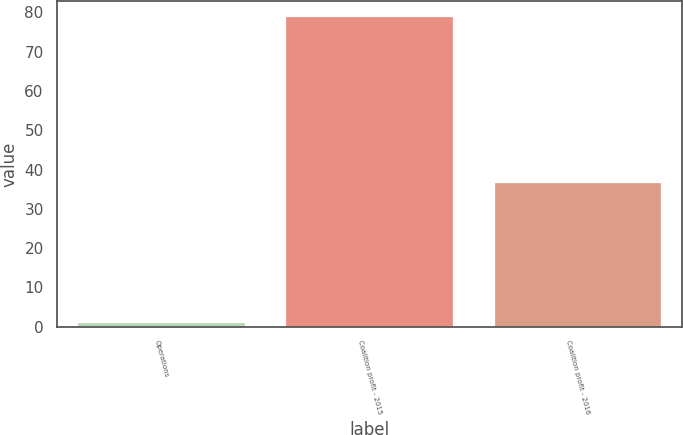Convert chart to OTSL. <chart><loc_0><loc_0><loc_500><loc_500><bar_chart><fcel>Operations<fcel>Coalition profit - 2015<fcel>Coalition profit - 2016<nl><fcel>0.9<fcel>78.9<fcel>36.6<nl></chart> 